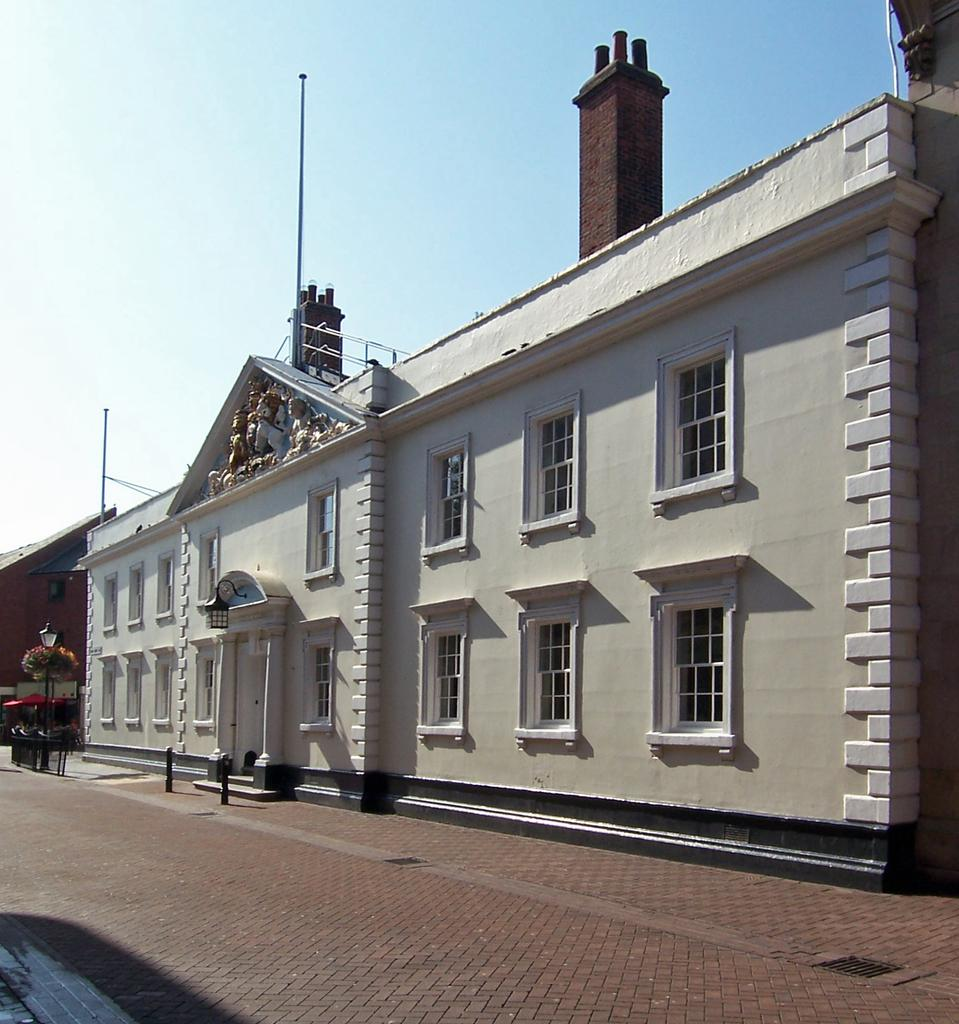What type of structures can be seen in the image? There are buildings in the image. What can be seen illuminating the scene in the image? Lights are present in the image. What are the vertical structures supporting the lights? Poles are visible in the image. What type of vegetation is present in the image? Plants are in the image. What decorative elements can be seen on the wall in the image? There are statues on a wall in the image. What openings are present in the buildings in the image? Windows are present in the image. What architectural features are at the top of the building in the image? Pillars are at the top of the building in the image. What part of the natural environment is visible in the image? The sky is visible in the image. Where is the library located in the image? There is no mention of a library in the image. What type of writing instrument is being used by the statue in the image? There are no statues holding writing instruments in the image. What type of battle is taking place in the image? There is no battle depicted in the image. 